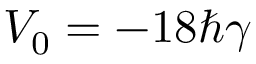Convert formula to latex. <formula><loc_0><loc_0><loc_500><loc_500>V _ { 0 } = - 1 8 \hbar { \gamma }</formula> 